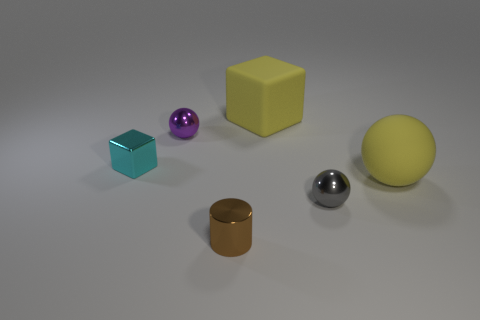Add 2 small gray cylinders. How many objects exist? 8 Subtract all blocks. How many objects are left? 4 Subtract 0 purple cubes. How many objects are left? 6 Subtract all tiny cyan matte objects. Subtract all tiny brown cylinders. How many objects are left? 5 Add 3 cyan objects. How many cyan objects are left? 4 Add 1 large purple matte blocks. How many large purple matte blocks exist? 1 